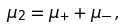<formula> <loc_0><loc_0><loc_500><loc_500>\mu _ { 2 } = \mu _ { + } + \mu _ { - } \, ,</formula> 